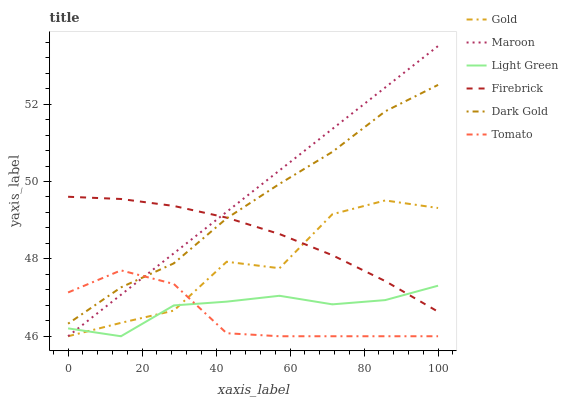Does Tomato have the minimum area under the curve?
Answer yes or no. Yes. Does Maroon have the maximum area under the curve?
Answer yes or no. Yes. Does Gold have the minimum area under the curve?
Answer yes or no. No. Does Gold have the maximum area under the curve?
Answer yes or no. No. Is Maroon the smoothest?
Answer yes or no. Yes. Is Gold the roughest?
Answer yes or no. Yes. Is Dark Gold the smoothest?
Answer yes or no. No. Is Dark Gold the roughest?
Answer yes or no. No. Does Tomato have the lowest value?
Answer yes or no. Yes. Does Dark Gold have the lowest value?
Answer yes or no. No. Does Maroon have the highest value?
Answer yes or no. Yes. Does Gold have the highest value?
Answer yes or no. No. Is Tomato less than Firebrick?
Answer yes or no. Yes. Is Dark Gold greater than Light Green?
Answer yes or no. Yes. Does Firebrick intersect Light Green?
Answer yes or no. Yes. Is Firebrick less than Light Green?
Answer yes or no. No. Is Firebrick greater than Light Green?
Answer yes or no. No. Does Tomato intersect Firebrick?
Answer yes or no. No. 